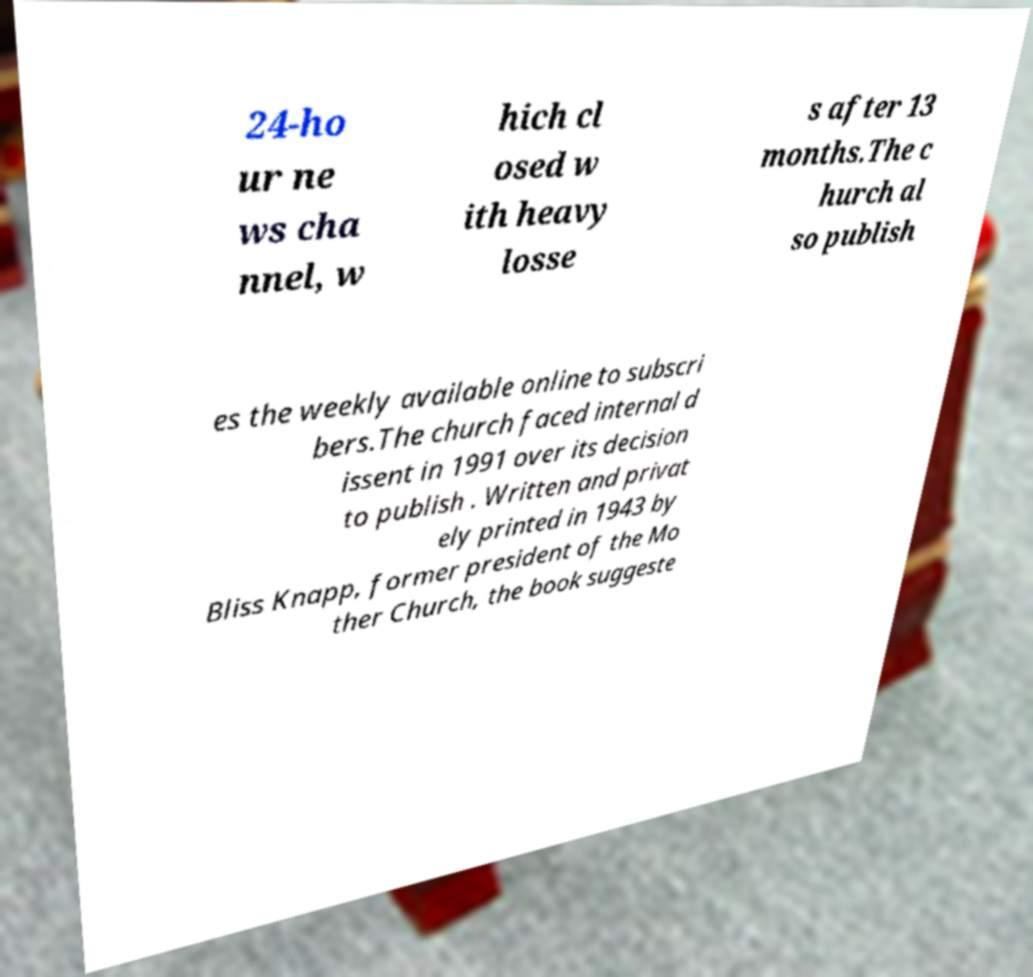Could you assist in decoding the text presented in this image and type it out clearly? 24-ho ur ne ws cha nnel, w hich cl osed w ith heavy losse s after 13 months.The c hurch al so publish es the weekly available online to subscri bers.The church faced internal d issent in 1991 over its decision to publish . Written and privat ely printed in 1943 by Bliss Knapp, former president of the Mo ther Church, the book suggeste 